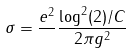<formula> <loc_0><loc_0><loc_500><loc_500>\sigma = \frac { e ^ { 2 } } { } \frac { \log ^ { 2 } ( 2 ) / C } { 2 \pi g ^ { 2 } }</formula> 